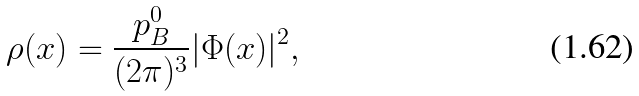Convert formula to latex. <formula><loc_0><loc_0><loc_500><loc_500>\rho ( x ) = \frac { p ^ { 0 } _ { B } } { ( 2 \pi ) ^ { 3 } } | \Phi ( x ) | ^ { 2 } ,</formula> 